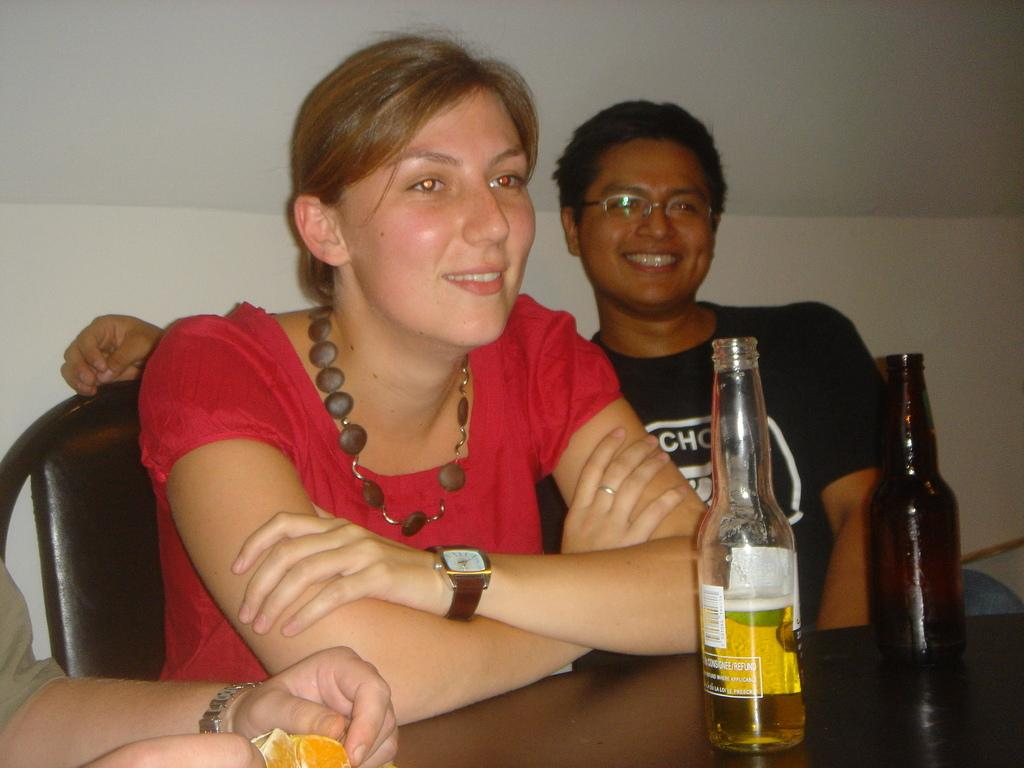How many people are in the image? There are three people in the image. What are the people doing in the image? The people are seated on chairs. What objects can be seen on the table in the image? There are two bottles on a table. What type of scissors are being used by the people in the image? There are no scissors present in the image; the people are simply seated on chairs. 